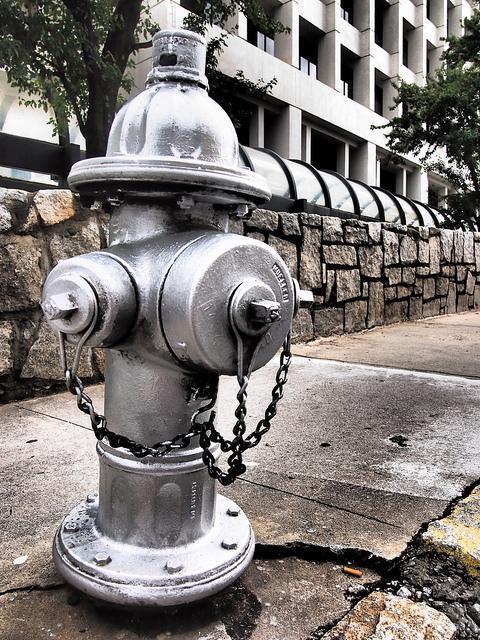How many people are holding up their camera phones?
Give a very brief answer. 0. 